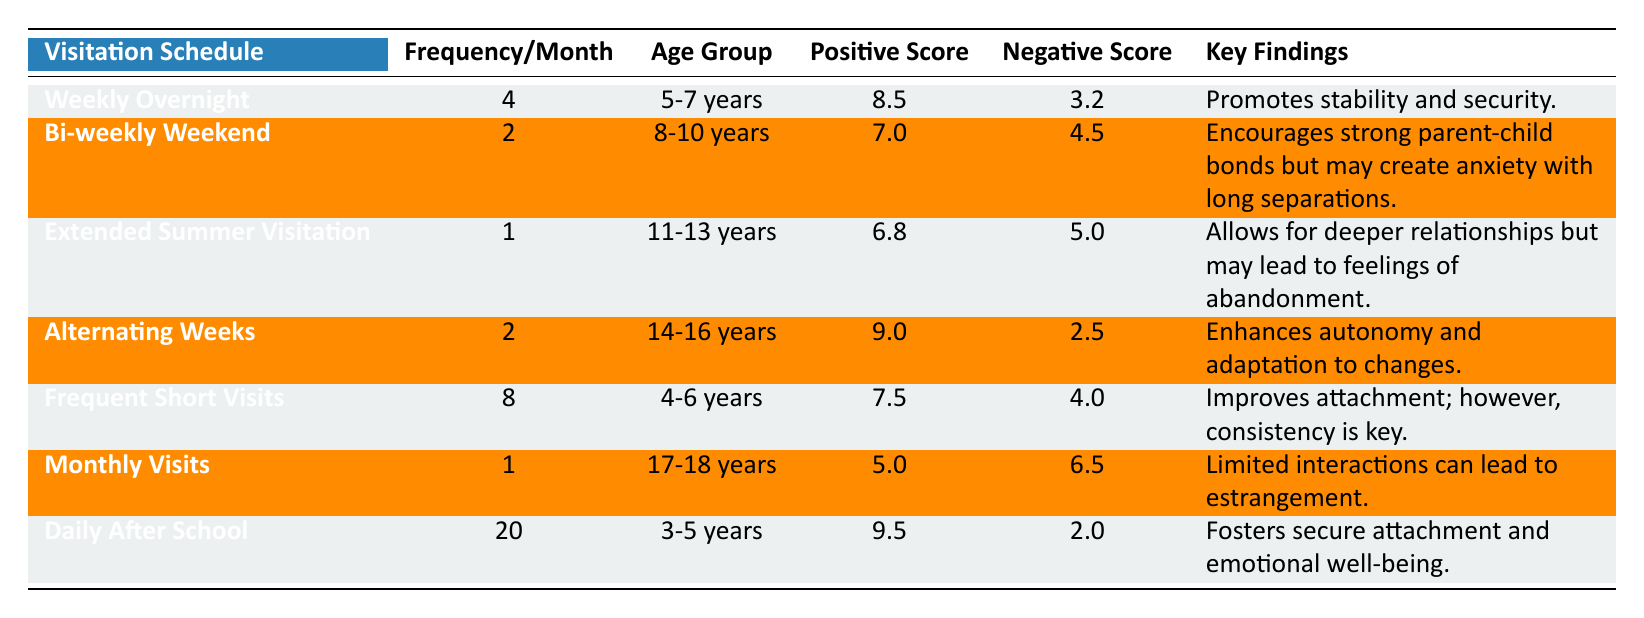What is the positive outcome score for the "Daily After School" visitation schedule? The positive outcome score for "Daily After School" is listed in the table under that schedule type. It is found in the column for positive scores.
Answer: 9.5 How many monthly visits correspond to the "Bi-weekly Weekend" schedule? The table indicates that the frequency per month for "Bi-weekly Weekend" is shown under the Frequency/Month column. It states that the frequency is 2.
Answer: 2 Which visitation schedule has the highest negative outcome score? By reviewing the negative outcome scores across all visitation schedules in the table, the "Monthly Visits" schedule has the highest score of 6.5.
Answer: Monthly Visits What is the average positive outcome score for all visitation schedules? The positive outcome scores are 8.5, 7.0, 6.8, 9.0, 7.5, 5.0, and 9.5. Summing these scores gives a total of 53.3, and there are 7 schedules, so the average is 53.3 / 7 = 7.61.
Answer: 7.61 Does the "Extended Summer Visitation" schedule promote stronger attachment than the "Alternating Weeks" schedule based on positive outcome scores? The positive outcome score for "Extended Summer Visitation" is 6.8, while for "Alternating Weeks," it is 9.0. Since 6.8 is less than 9.0, the statement is false.
Answer: No Which age group benefits the most from frequent short visits according to the scores? The "Frequent Short Visits" schedule, which has a positive outcome score of 7.5, corresponds to the age group of 4-6 years. It shows significant improvement in attachment compared to other schedules for this age group.
Answer: 4-6 years What is the key finding associated with "Weekly Overnight" visitation? The table provides a key findings column that indicates "Promotes stability and security" under the "Weekly Overnight" schedule.
Answer: Promotes stability and security What is the total frequency of visitation across all schedules for the 3-5 years age group? The table shows that the "Daily After School" schedule has a frequency of 20, while there are no other schedules for the 3-5 years group. Thus, the total frequency is 20.
Answer: 20 Which visitation schedule has the highest frequency per month? By assessing the frequency column, "Daily After School" shows a frequency of 20 per month, which is the highest compared to other schedules.
Answer: Daily After School Do children aged 11-13 years benefit more from extended summer visitation than children aged 17-18 years from monthly visits? The positive outcome for 11-13 years with "Extended Summer Visitation" is 6.8, while 17-18 years with "Monthly Visits" is 5.0. Since 6.8 is greater than 5.0, children aged 11-13 years benefit more.
Answer: Yes 